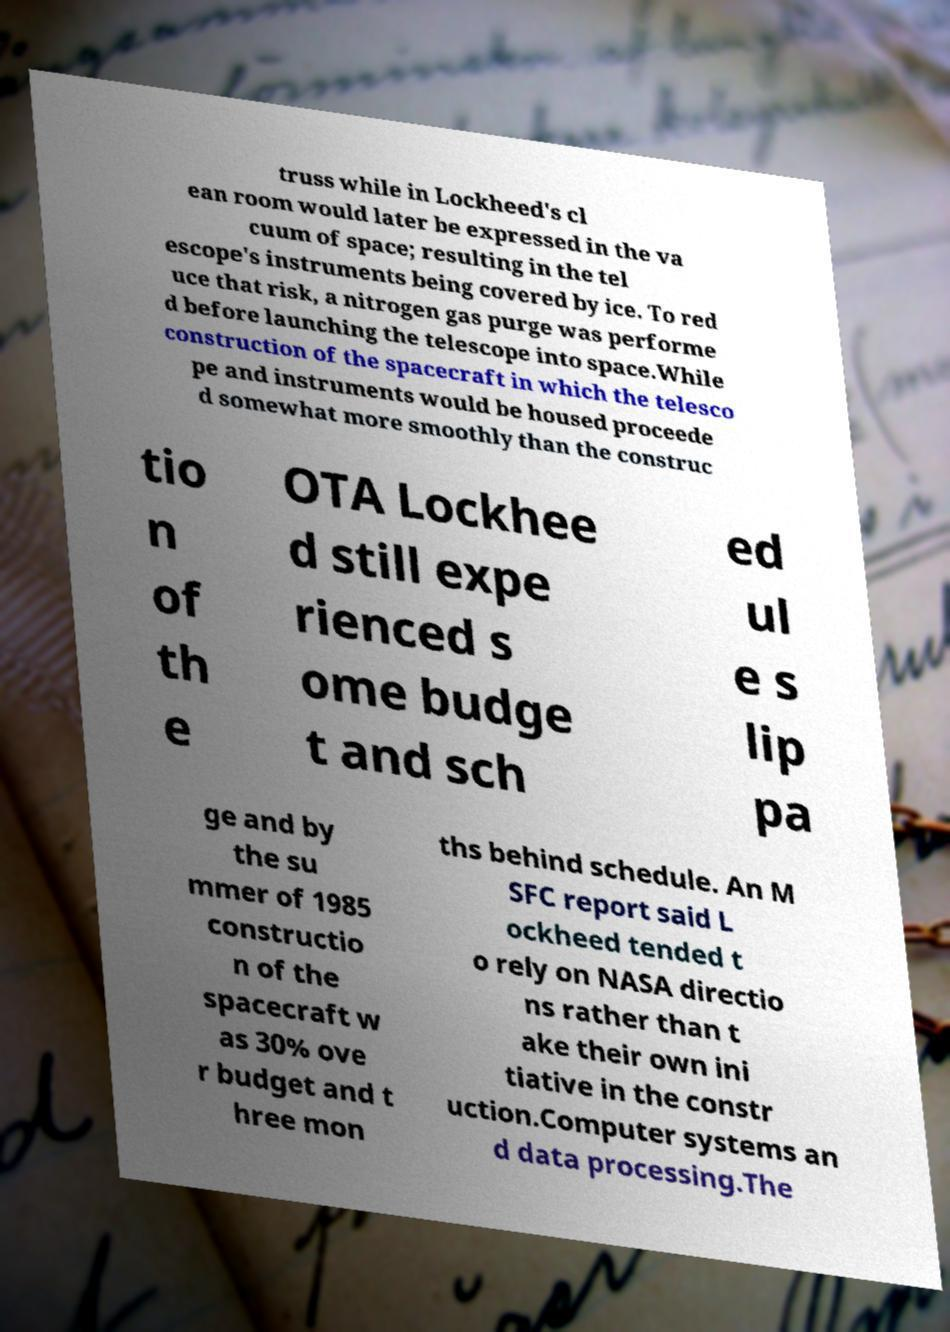What messages or text are displayed in this image? I need them in a readable, typed format. truss while in Lockheed's cl ean room would later be expressed in the va cuum of space; resulting in the tel escope's instruments being covered by ice. To red uce that risk, a nitrogen gas purge was performe d before launching the telescope into space.While construction of the spacecraft in which the telesco pe and instruments would be housed proceede d somewhat more smoothly than the construc tio n of th e OTA Lockhee d still expe rienced s ome budge t and sch ed ul e s lip pa ge and by the su mmer of 1985 constructio n of the spacecraft w as 30% ove r budget and t hree mon ths behind schedule. An M SFC report said L ockheed tended t o rely on NASA directio ns rather than t ake their own ini tiative in the constr uction.Computer systems an d data processing.The 